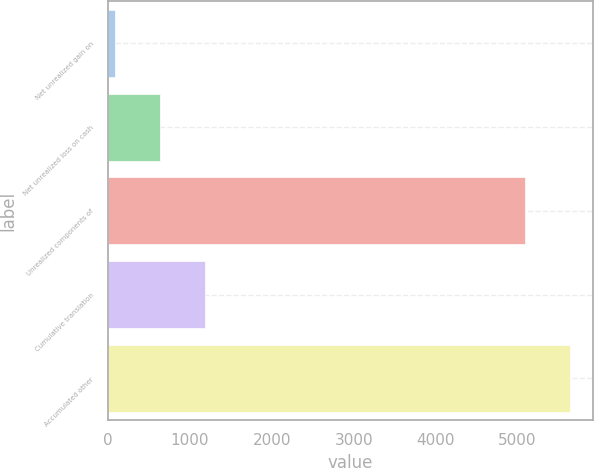Convert chart. <chart><loc_0><loc_0><loc_500><loc_500><bar_chart><fcel>Net unrealized gain on<fcel>Net unrealized loss on cash<fcel>Unrealized components of<fcel>Cumulative translation<fcel>Accumulated other<nl><fcel>87<fcel>634.2<fcel>5090<fcel>1181.4<fcel>5637.2<nl></chart> 